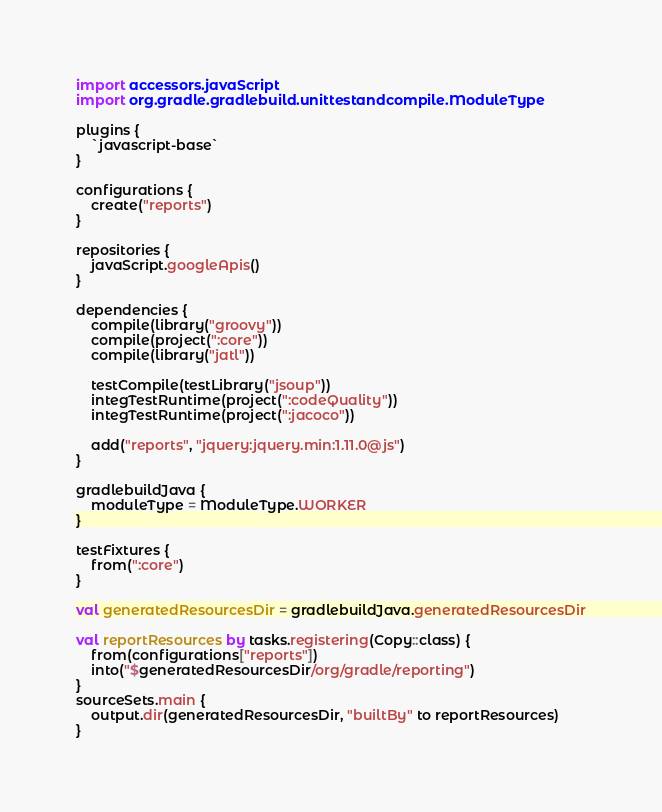<code> <loc_0><loc_0><loc_500><loc_500><_Kotlin_>import accessors.javaScript
import org.gradle.gradlebuild.unittestandcompile.ModuleType

plugins {
    `javascript-base`
}

configurations {
    create("reports")
}

repositories {
    javaScript.googleApis()
}

dependencies {
    compile(library("groovy"))
    compile(project(":core"))
    compile(library("jatl"))

    testCompile(testLibrary("jsoup"))
    integTestRuntime(project(":codeQuality"))
    integTestRuntime(project(":jacoco"))

    add("reports", "jquery:jquery.min:1.11.0@js")
}

gradlebuildJava {
    moduleType = ModuleType.WORKER
}

testFixtures {
    from(":core")
}

val generatedResourcesDir = gradlebuildJava.generatedResourcesDir

val reportResources by tasks.registering(Copy::class) {
    from(configurations["reports"])
    into("$generatedResourcesDir/org/gradle/reporting")
}
sourceSets.main {
    output.dir(generatedResourcesDir, "builtBy" to reportResources)
}
</code> 